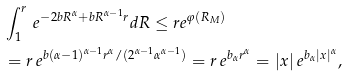Convert formula to latex. <formula><loc_0><loc_0><loc_500><loc_500>& \int _ { 1 } ^ { r } \, e ^ { - 2 b R ^ { \alpha } + b R ^ { \alpha - 1 } r } d R \leq r e ^ { \varphi ( R _ { M } ) } \\ & = r \, e ^ { b ( \alpha - 1 ) ^ { \alpha - 1 } r ^ { \alpha } / ( 2 ^ { \alpha - 1 } \alpha ^ { \alpha - 1 } ) } = r \, e ^ { b _ { \alpha } r ^ { \alpha } } = | x | \, e ^ { b _ { \alpha } | x | ^ { \alpha } } ,</formula> 